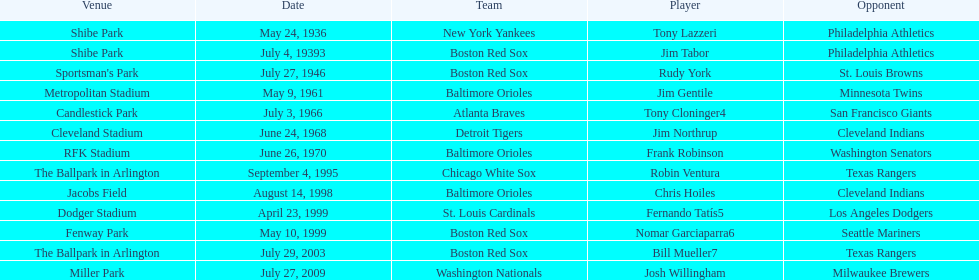Who was the opponent for the boston red sox on july 27, 1946? St. Louis Browns. 